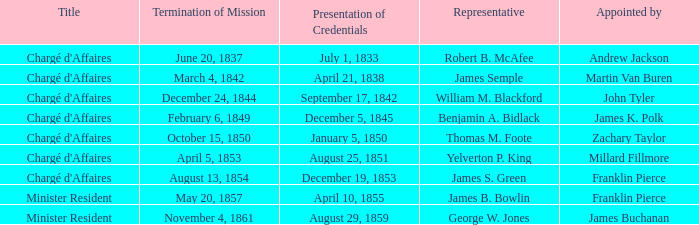Which Title has an Appointed by of Millard Fillmore? Chargé d'Affaires. 